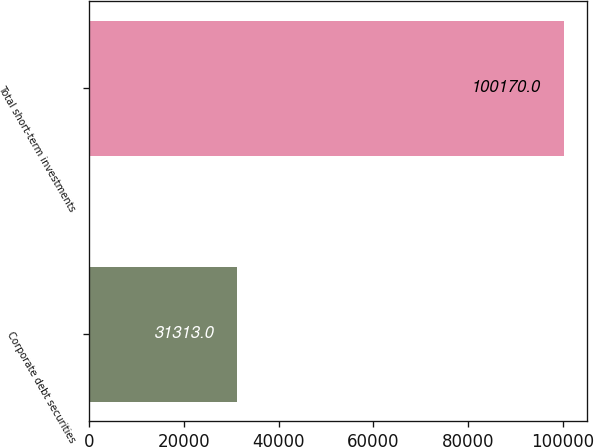Convert chart. <chart><loc_0><loc_0><loc_500><loc_500><bar_chart><fcel>Corporate debt securities<fcel>Total short-term investments<nl><fcel>31313<fcel>100170<nl></chart> 